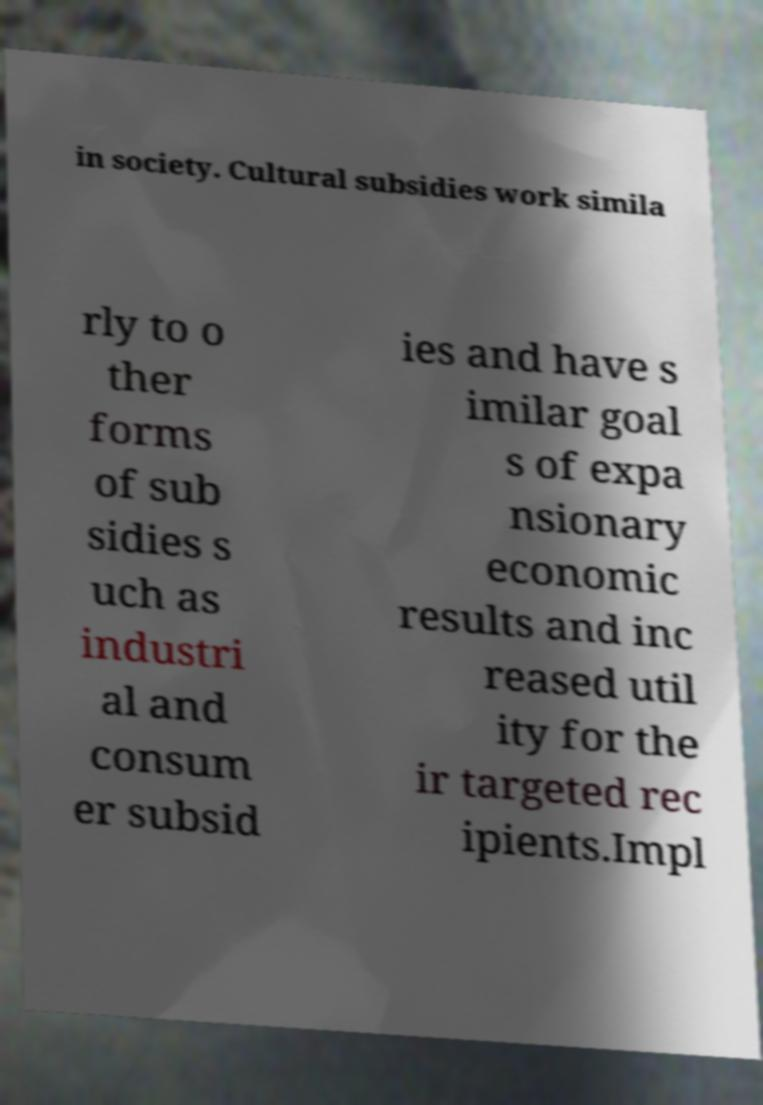Could you extract and type out the text from this image? in society. Cultural subsidies work simila rly to o ther forms of sub sidies s uch as industri al and consum er subsid ies and have s imilar goal s of expa nsionary economic results and inc reased util ity for the ir targeted rec ipients.Impl 